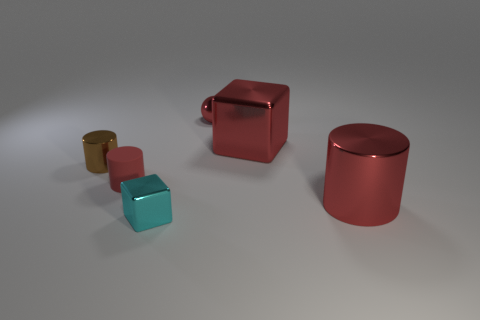Does the red shiny thing that is left of the red metallic block have the same size as the red metallic cylinder?
Provide a short and direct response. No. There is a shiny block in front of the cylinder that is to the right of the large shiny block; what number of large metal objects are to the right of it?
Ensure brevity in your answer.  2. What number of gray objects are either tiny metallic cylinders or tiny objects?
Ensure brevity in your answer.  0. What color is the big block that is the same material as the brown cylinder?
Keep it short and to the point. Red. Are there any other things that are the same size as the brown object?
Keep it short and to the point. Yes. How many small objects are cyan blocks or brown rubber cubes?
Offer a very short reply. 1. Are there fewer big red cylinders than big purple metallic cylinders?
Your response must be concise. No. What color is the other tiny thing that is the same shape as the brown metal thing?
Your answer should be very brief. Red. Is there anything else that is the same shape as the brown shiny thing?
Offer a very short reply. Yes. Are there more big red rubber cylinders than things?
Provide a succinct answer. No. 